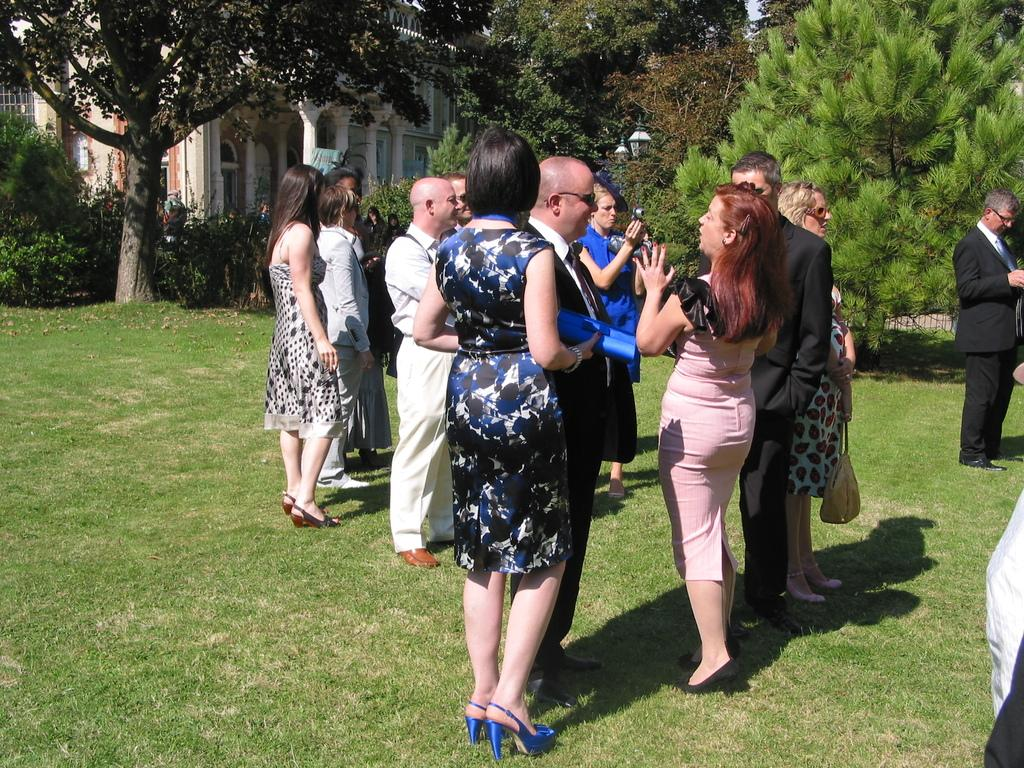How many groups of people can be seen in the image? There are multiple groups of people in the image. What is the setting of the image? The image features grass, trees, and houses, suggesting an outdoor or park-like setting. What object is visible that is typically used for capturing images? There is a camera visible in the image. What type of vegetation is present in the image? There are trees in the image. What type of paste is being used by the people in the image? There is no paste visible or mentioned in the image. How many bulbs are hanging from the trees in the image? There are no bulbs present in the image; it features trees, grass, and houses. 